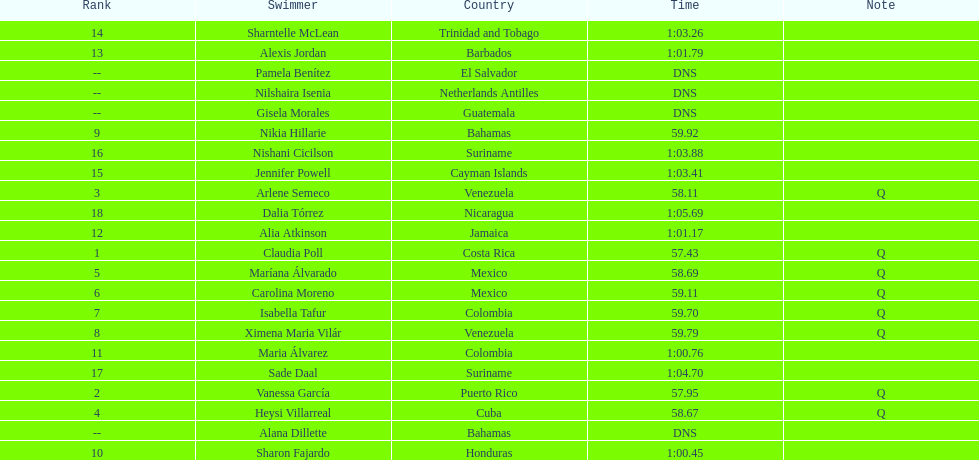Who was the last competitor to actually finish the preliminaries? Dalia Tórrez. 